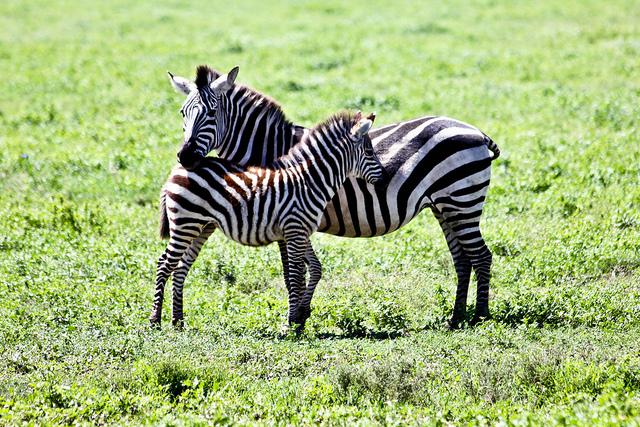Are the zebras related?
Quick response, please. Yes. Are the zebra grazing?
Keep it brief. No. Is the bigger Zebra moving in this photo?
Concise answer only. No. Is the photographer physically close to the zebras?
Answer briefly. No. How many stripes are there?
Short answer required. 50. 